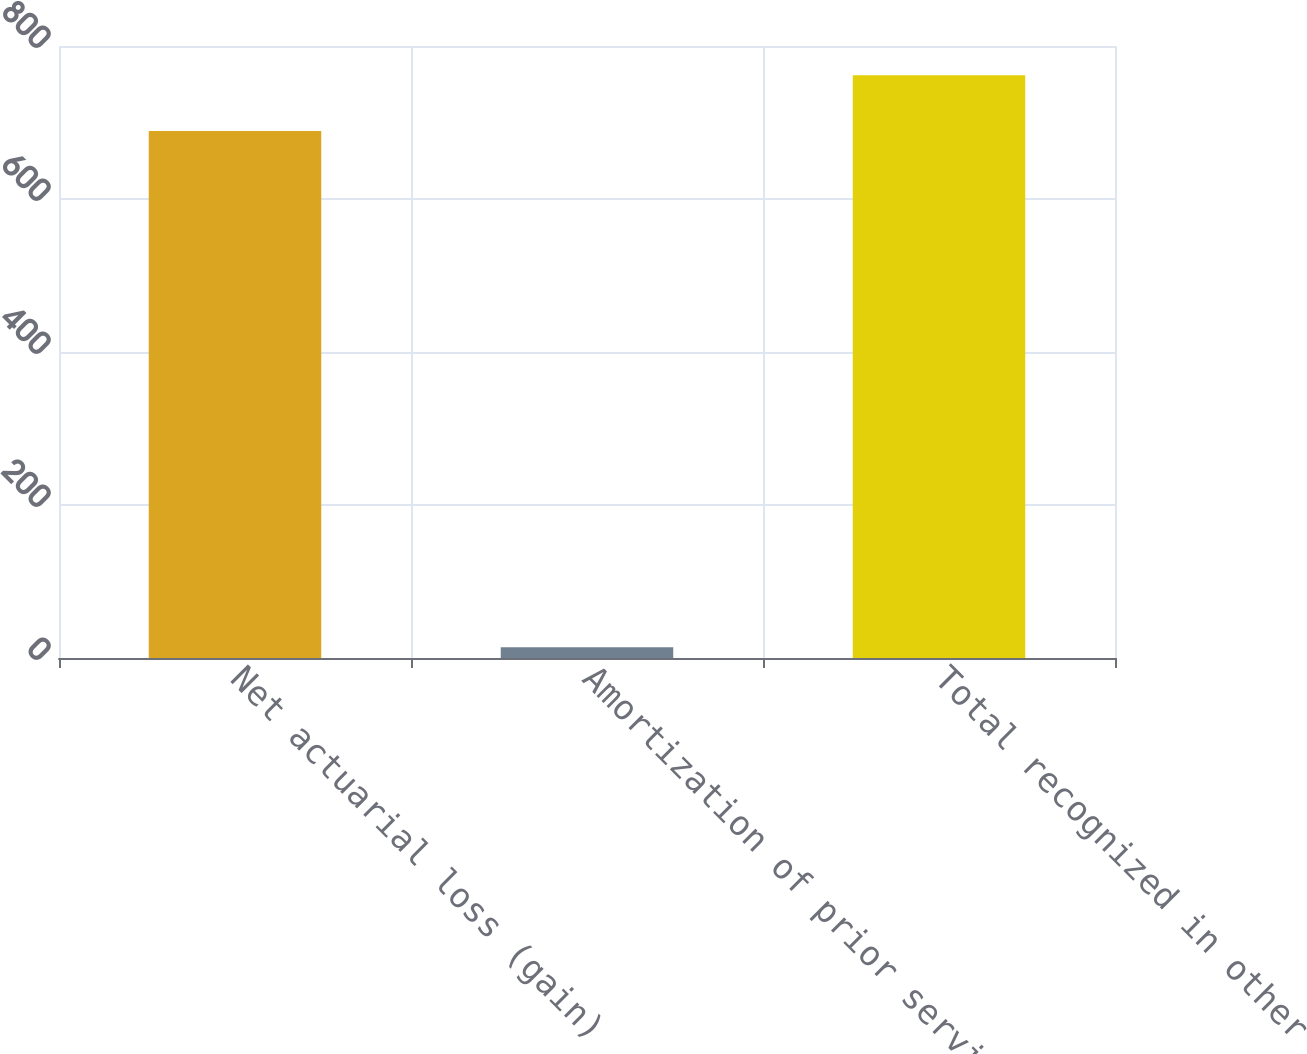Convert chart. <chart><loc_0><loc_0><loc_500><loc_500><bar_chart><fcel>Net actuarial loss (gain)<fcel>Amortization of prior service<fcel>Total recognized in other<nl><fcel>689<fcel>14<fcel>761.9<nl></chart> 